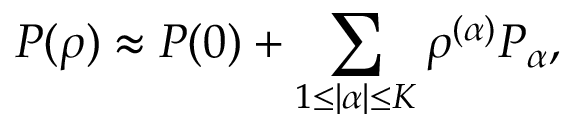Convert formula to latex. <formula><loc_0><loc_0><loc_500><loc_500>P ( \rho ) \approx P ( 0 ) + \sum _ { 1 \leq | \alpha | \leq K } \rho ^ { ( \alpha ) } P _ { \alpha } ,</formula> 